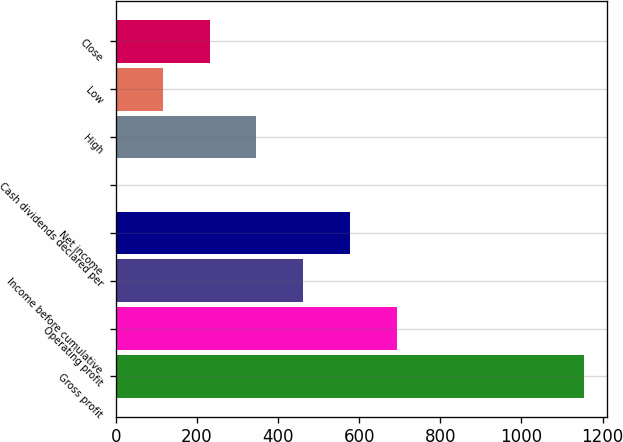Convert chart. <chart><loc_0><loc_0><loc_500><loc_500><bar_chart><fcel>Gross profit<fcel>Operating profit<fcel>Income before cumulative<fcel>Net income<fcel>Cash dividends declared per<fcel>High<fcel>Low<fcel>Close<nl><fcel>1153.1<fcel>692.05<fcel>461.53<fcel>576.79<fcel>0.49<fcel>346.27<fcel>115.75<fcel>231.01<nl></chart> 